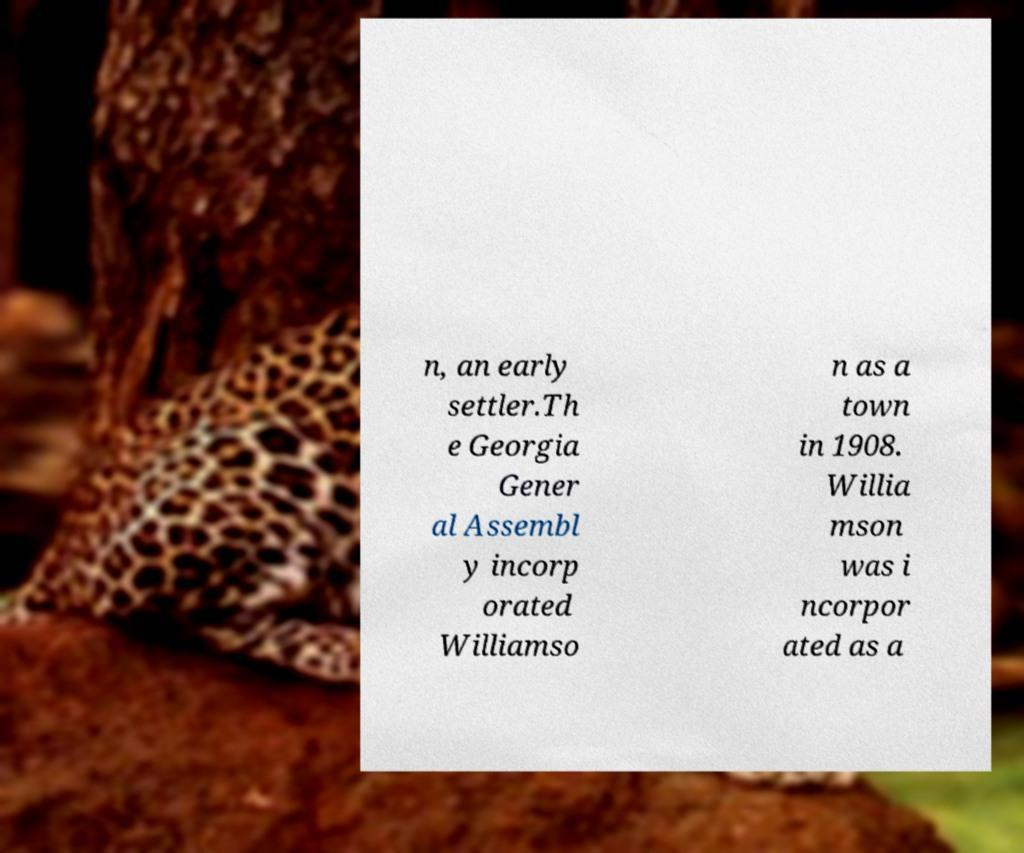What messages or text are displayed in this image? I need them in a readable, typed format. n, an early settler.Th e Georgia Gener al Assembl y incorp orated Williamso n as a town in 1908. Willia mson was i ncorpor ated as a 